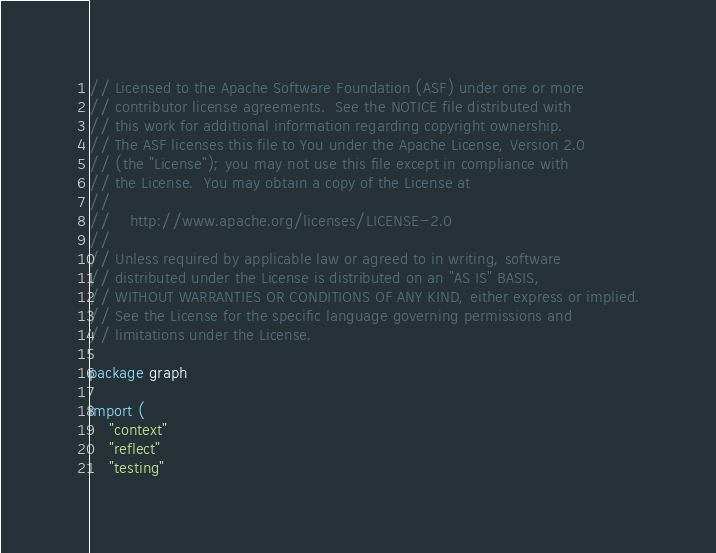Convert code to text. <code><loc_0><loc_0><loc_500><loc_500><_Go_>// Licensed to the Apache Software Foundation (ASF) under one or more
// contributor license agreements.  See the NOTICE file distributed with
// this work for additional information regarding copyright ownership.
// The ASF licenses this file to You under the Apache License, Version 2.0
// (the "License"); you may not use this file except in compliance with
// the License.  You may obtain a copy of the License at
//
//    http://www.apache.org/licenses/LICENSE-2.0
//
// Unless required by applicable law or agreed to in writing, software
// distributed under the License is distributed on an "AS IS" BASIS,
// WITHOUT WARRANTIES OR CONDITIONS OF ANY KIND, either express or implied.
// See the License for the specific language governing permissions and
// limitations under the License.

package graph

import (
	"context"
	"reflect"
	"testing"
</code> 